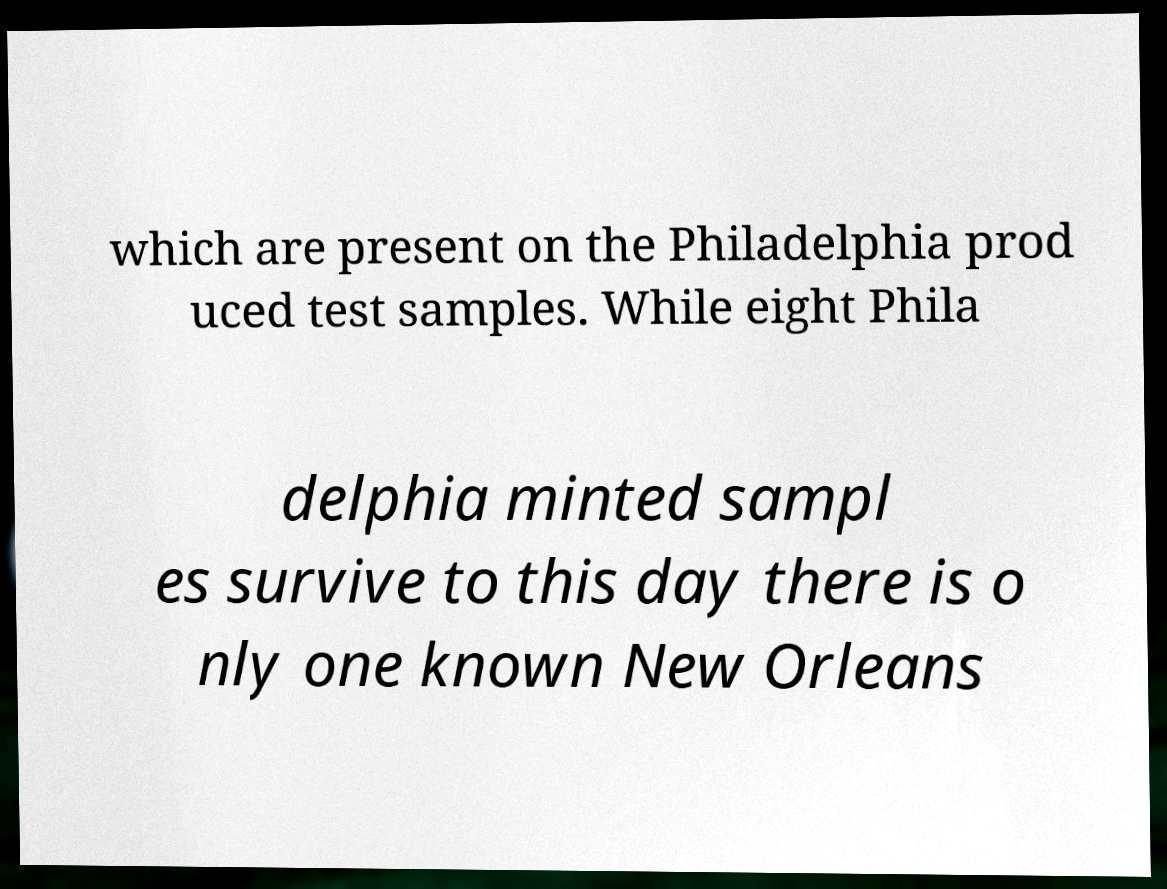Can you accurately transcribe the text from the provided image for me? which are present on the Philadelphia prod uced test samples. While eight Phila delphia minted sampl es survive to this day there is o nly one known New Orleans 